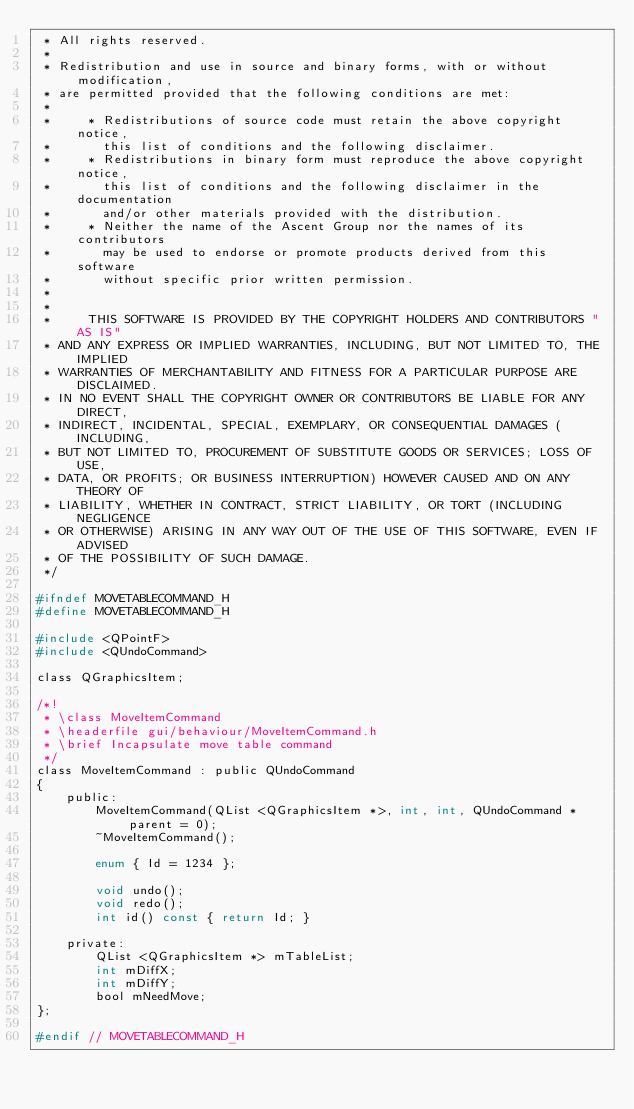<code> <loc_0><loc_0><loc_500><loc_500><_C_> * All rights reserved.
 *
 * Redistribution and use in source and binary forms, with or without modification,
 * are permitted provided that the following conditions are met:
 *
 *     * Redistributions of source code must retain the above copyright notice,
 *       this list of conditions and the following disclaimer.
 *     * Redistributions in binary form must reproduce the above copyright notice,
 *       this list of conditions and the following disclaimer in the documentation
 *       and/or other materials provided with the distribution.
 *     * Neither the name of the Ascent Group nor the names of its contributors
 *       may be used to endorse or promote products derived from this software
 *       without specific prior written permission.
 *
 *
 *     THIS SOFTWARE IS PROVIDED BY THE COPYRIGHT HOLDERS AND CONTRIBUTORS "AS IS"
 * AND ANY EXPRESS OR IMPLIED WARRANTIES, INCLUDING, BUT NOT LIMITED TO, THE IMPLIED
 * WARRANTIES OF MERCHANTABILITY AND FITNESS FOR A PARTICULAR PURPOSE ARE DISCLAIMED.
 * IN NO EVENT SHALL THE COPYRIGHT OWNER OR CONTRIBUTORS BE LIABLE FOR ANY DIRECT,
 * INDIRECT, INCIDENTAL, SPECIAL, EXEMPLARY, OR CONSEQUENTIAL DAMAGES (INCLUDING,
 * BUT NOT LIMITED TO, PROCUREMENT OF SUBSTITUTE GOODS OR SERVICES; LOSS OF USE,
 * DATA, OR PROFITS; OR BUSINESS INTERRUPTION) HOWEVER CAUSED AND ON ANY THEORY OF
 * LIABILITY, WHETHER IN CONTRACT, STRICT LIABILITY, OR TORT (INCLUDING NEGLIGENCE
 * OR OTHERWISE) ARISING IN ANY WAY OUT OF THE USE OF THIS SOFTWARE, EVEN IF ADVISED
 * OF THE POSSIBILITY OF SUCH DAMAGE.
 */

#ifndef MOVETABLECOMMAND_H
#define MOVETABLECOMMAND_H

#include <QPointF>
#include <QUndoCommand>

class QGraphicsItem;

/*!
 * \class MoveItemCommand
 * \headerfile gui/behaviour/MoveItemCommand.h
 * \brief Incapsulate move table command
 */
class MoveItemCommand : public QUndoCommand
{
    public:
        MoveItemCommand(QList <QGraphicsItem *>, int, int, QUndoCommand *parent = 0);
        ~MoveItemCommand();

        enum { Id = 1234 };

        void undo();
        void redo();
        int id() const { return Id; }

    private:
        QList <QGraphicsItem *> mTableList;
        int mDiffX;
        int mDiffY;
        bool mNeedMove;
};

#endif // MOVETABLECOMMAND_H

</code> 